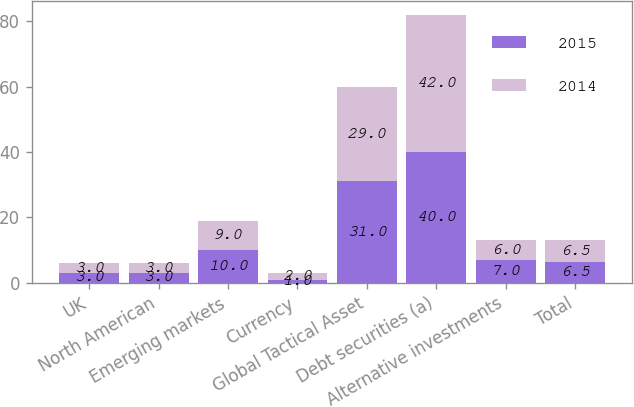Convert chart. <chart><loc_0><loc_0><loc_500><loc_500><stacked_bar_chart><ecel><fcel>UK<fcel>North American<fcel>Emerging markets<fcel>Currency<fcel>Global Tactical Asset<fcel>Debt securities (a)<fcel>Alternative investments<fcel>Total<nl><fcel>2015<fcel>3<fcel>3<fcel>10<fcel>1<fcel>31<fcel>40<fcel>7<fcel>6.5<nl><fcel>2014<fcel>3<fcel>3<fcel>9<fcel>2<fcel>29<fcel>42<fcel>6<fcel>6.5<nl></chart> 